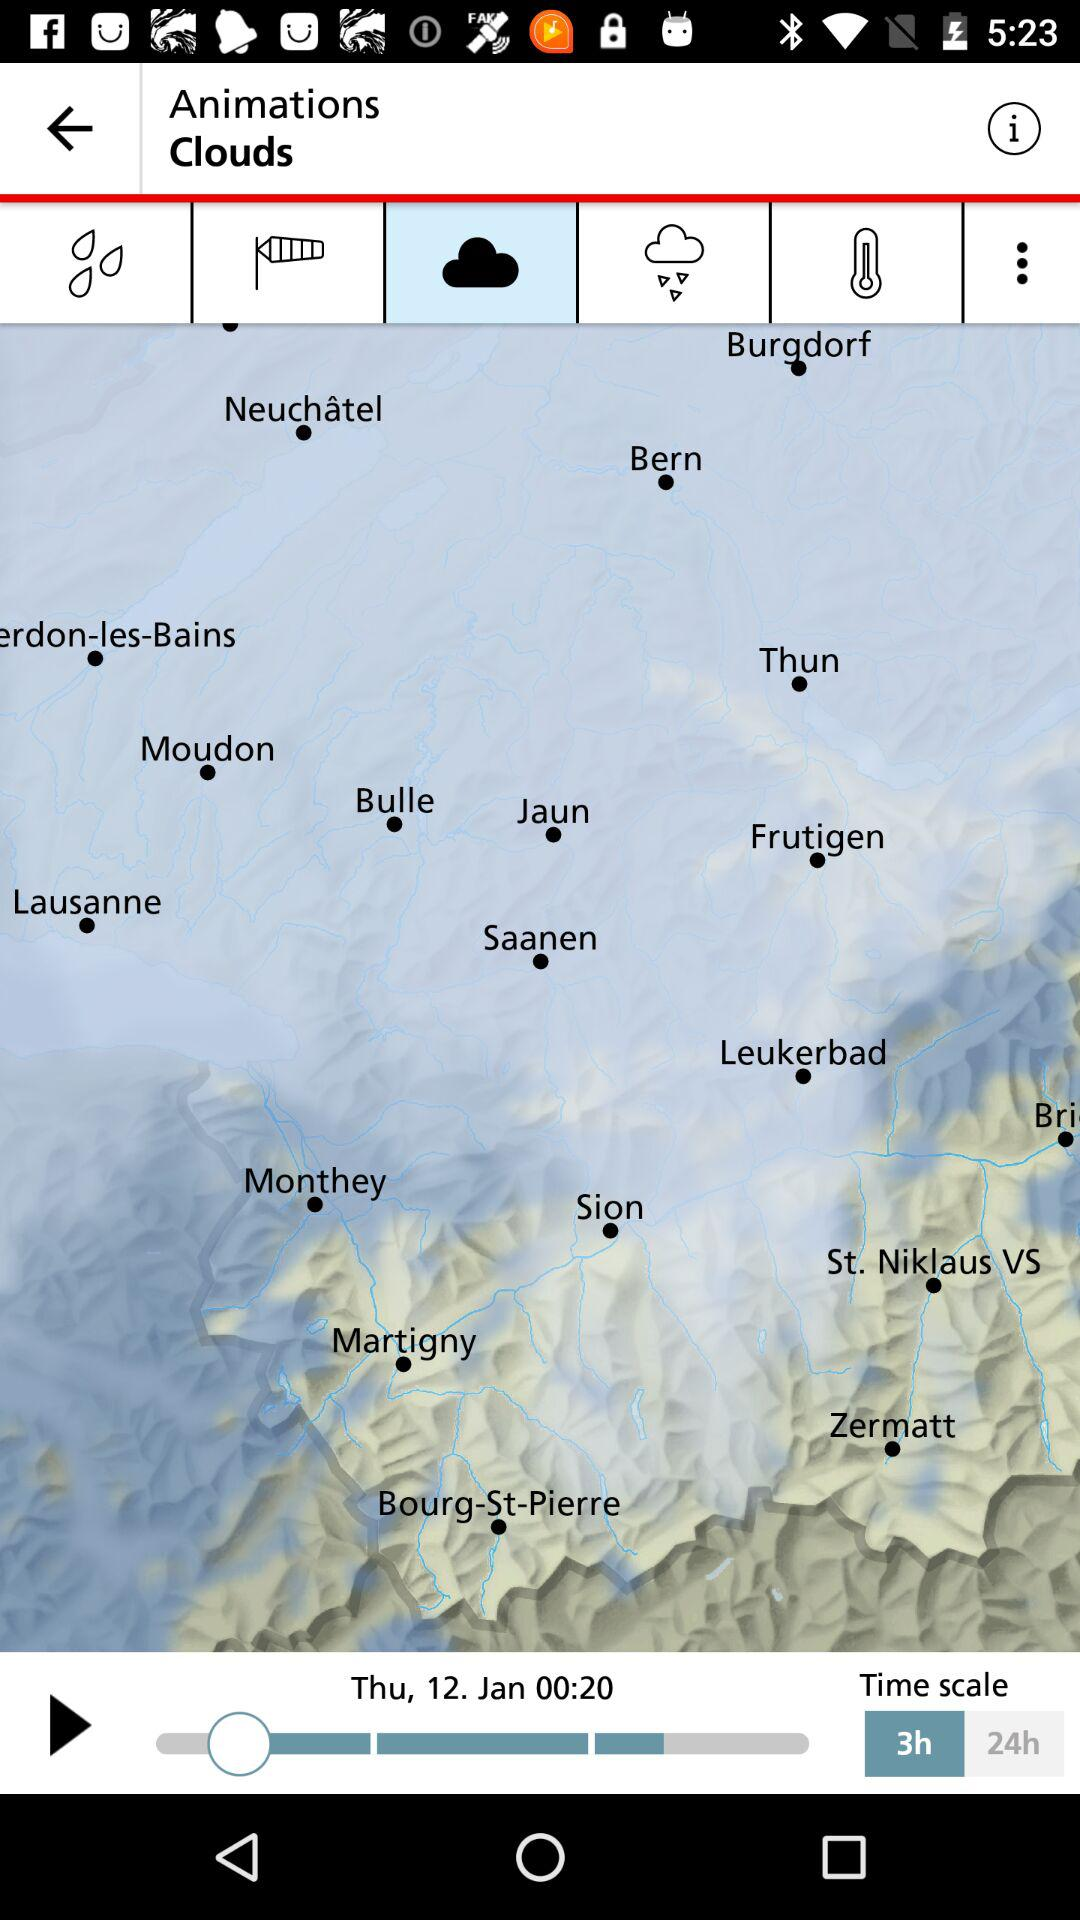What is the date and time mentioned on the map? The date is Thursday, January 12 and the time is 00:20. 